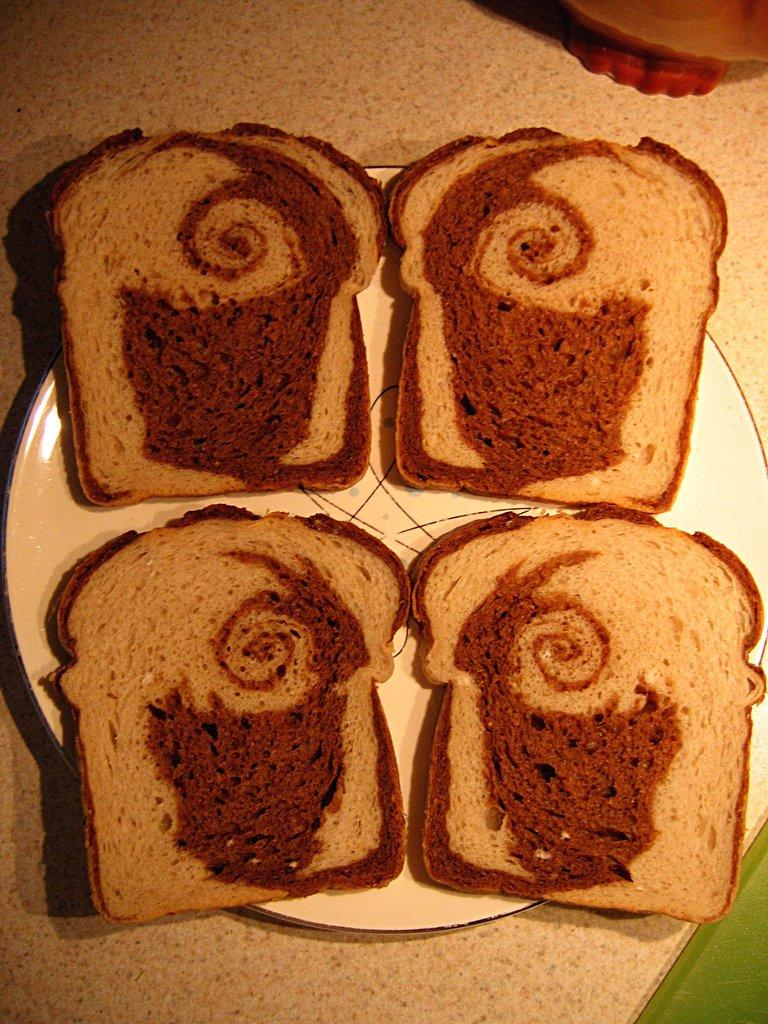What is on the plate that is visible in the image? There is food on a plate in the image. Can you describe anything else in the image besides the plate of food? There is an object on a table in the background of the image. How does the food on the plate push the object on the table in the image? The food on the plate does not push the object on the table in the image. There is no indication of any interaction between the food and the object. 